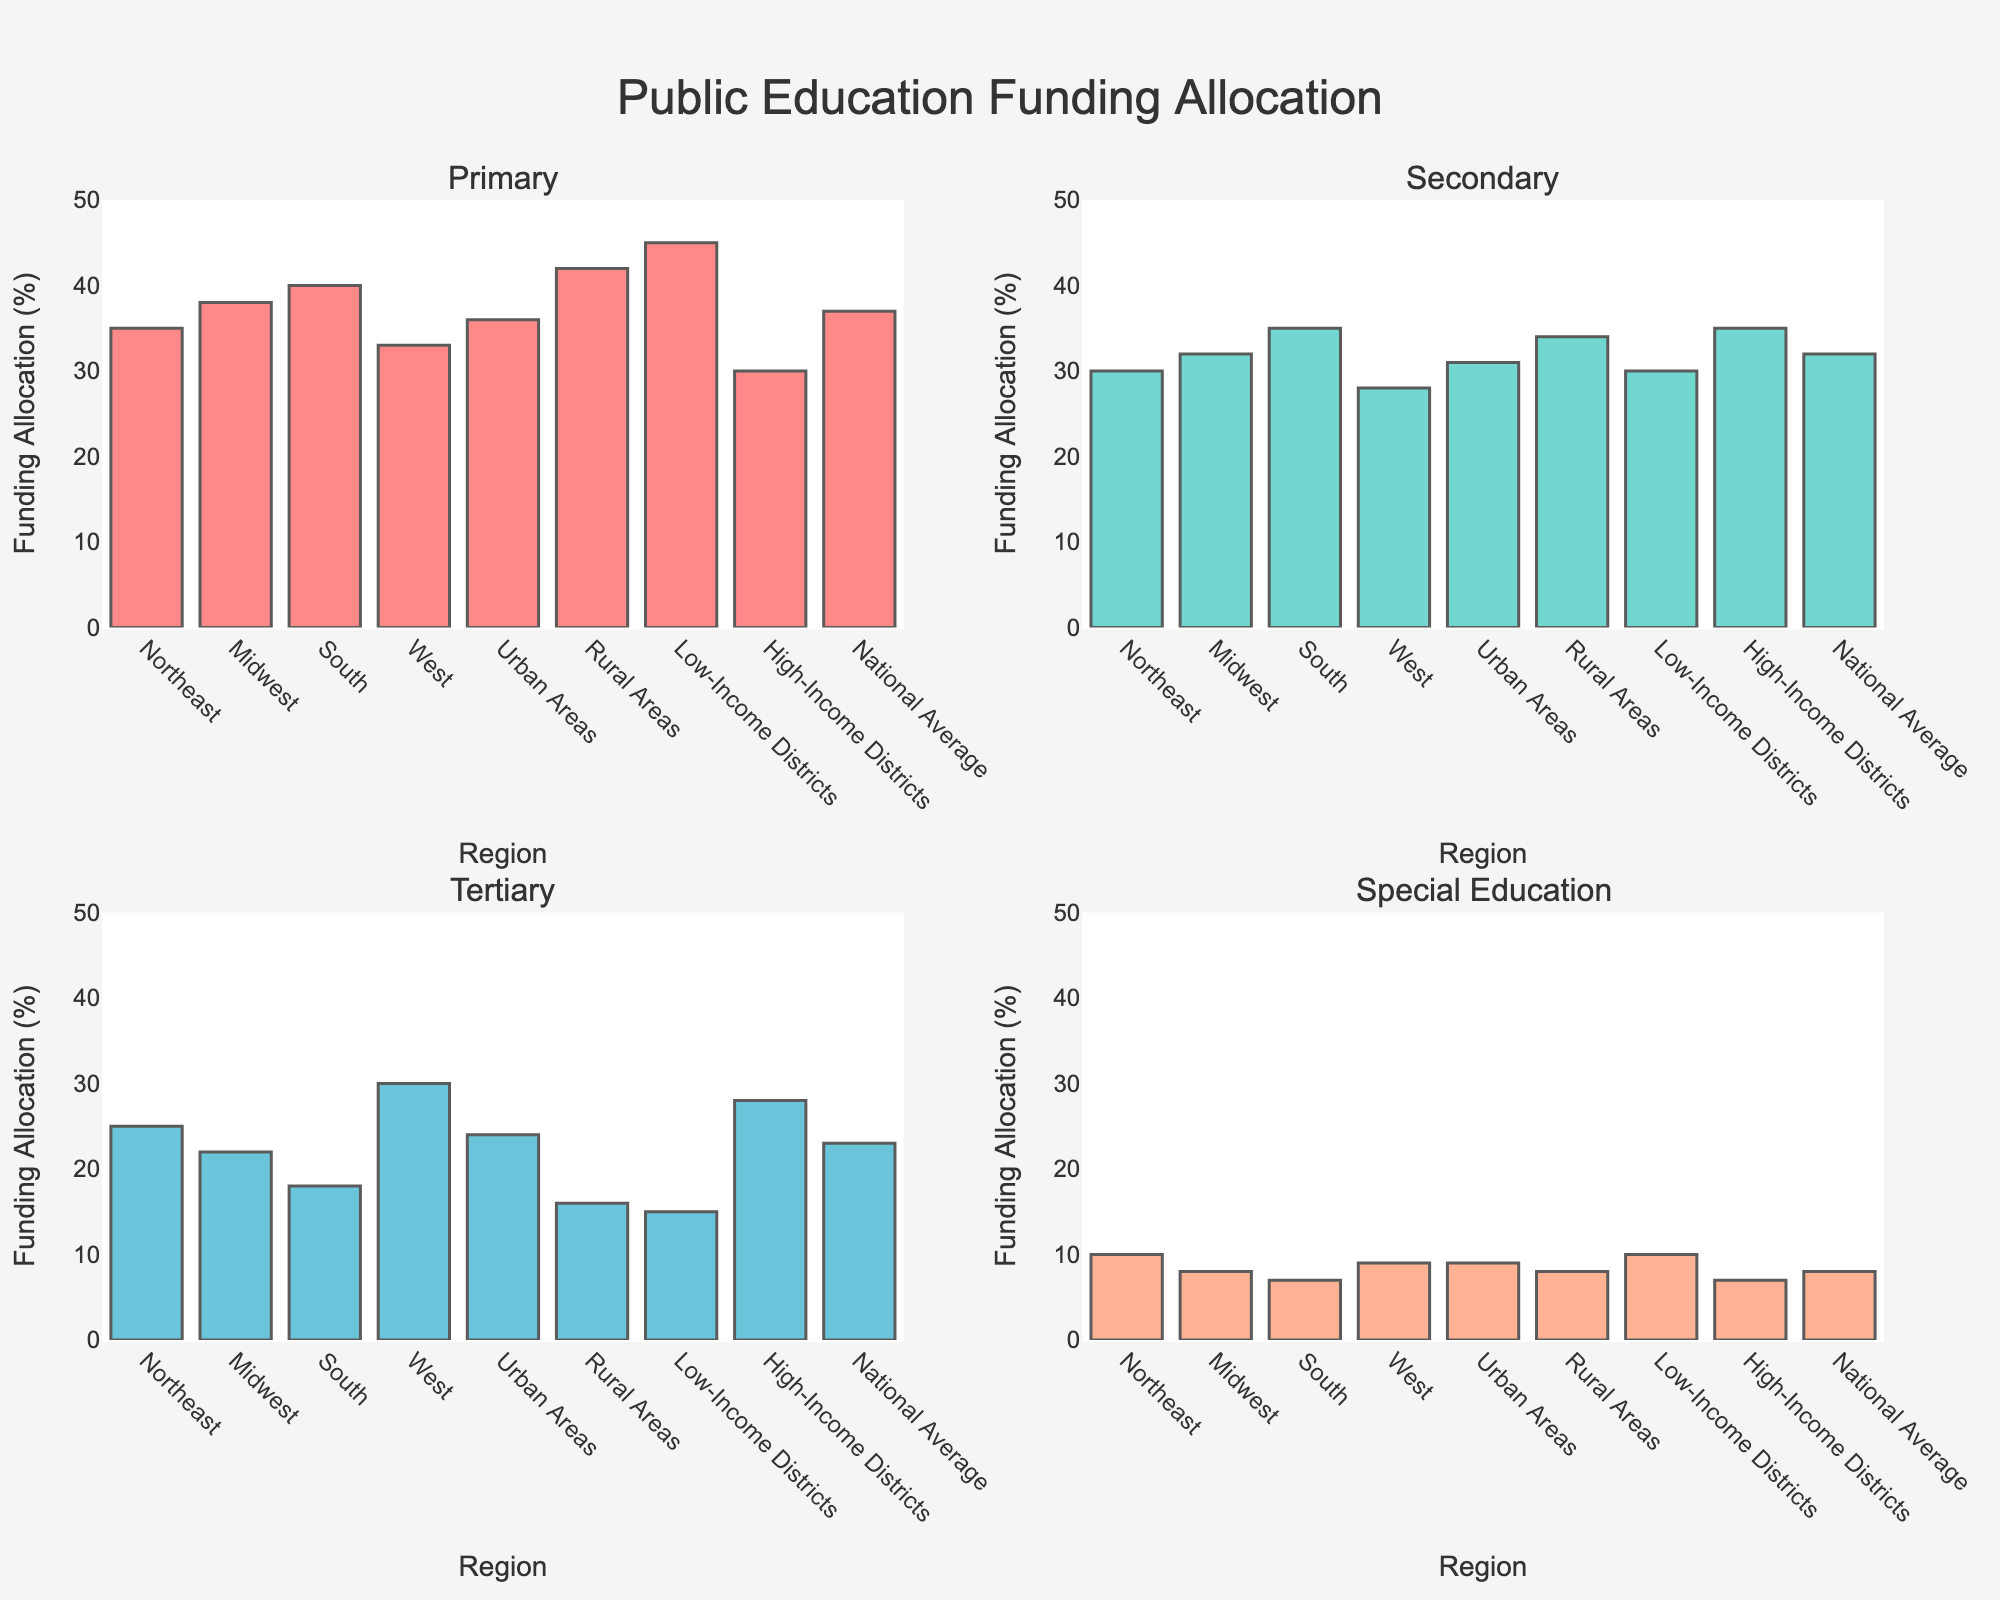Which region has the highest allocation for Primary education? Look at the bar for Primary education across all regions. The Rural Areas have the highest bar at 42%.
Answer: Rural Areas What is the difference in funding allocation for Special Education between Northeast and High-Income Districts? Compare the Special Education bars of the Northeast and High-Income Districts. The Northeast is at 10% and High-Income is at 7%. The difference is 10% - 7% = 3%.
Answer: 3% Which region has the lowest funding allocation in Secondary education and how much is it? Check the bars for Secondary education. Low-Income Districts have the smallest bar at 30%.
Answer: Low-Income Districts with 30% Compare the allocation for Tertiary education between West and South. Which region allocates more, and by how much? Look at the Tertiary education bars for West and South. West is at 30% and South is at 18%. The difference is 30% - 18% = 12%.
Answer: West allocates more by 12% What is the average funding allocation for Primary education across the regions? Sum all Primary education percentages and divide by the number of regions. (35 + 38 + 40 + 33 + 36 + 42 + 45 + 30 + 37) / 9 = 38%
Answer: 38% What is the total funding allocation for Tertiary education across all regions combined? Sum all Tertiary education percentages. 25 + 22 + 18 + 30 + 24 + 16 + 15 + 28 + 23 = 201% (Total)
Answer: 201% Identify two regions with the most similar funding allocation in Special Education. Compare the bars in Special Education for all regions. Midwest and Urban Areas both are close to 8% and 9%.
Answer: Midwest and Urban Areas In which educational category does South have the highest allocation compared to other categories? Compare South's allocation in all four categories. Primary education has the highest allocation at 40%.
Answer: Primary education What is the range of funding allocation for Secondary education across all regions? Find the maximum and minimum for Secondary education. The maximum is 35% (High-Income Districts and South), and the minimum is 30% (Northeast and Low-Income Districts). The range is 35 - 30 = 5%.
Answer: 5% How does the funding allocation for Primary education in Low-Income Districts compare to the National Average? Compare the bars for Primary education in Low-Income Districts (45%) and National Average (37%). Low-Income Districts allocate 8% more.
Answer: Low-Income Districts allocate 8% more 